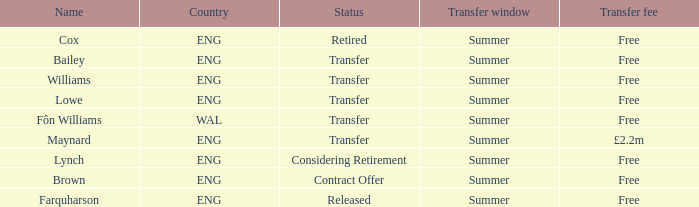What is the name of the free transfer fee with a transfer status and an ENG country? Bailey, Williams, Lowe. 